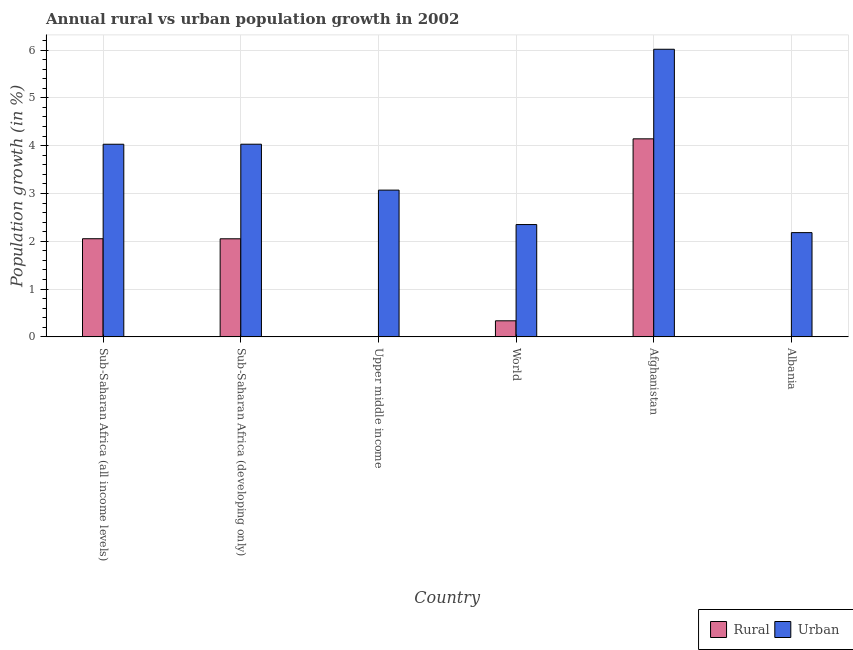How many bars are there on the 2nd tick from the right?
Your answer should be compact. 2. What is the label of the 1st group of bars from the left?
Provide a short and direct response. Sub-Saharan Africa (all income levels). Across all countries, what is the maximum rural population growth?
Make the answer very short. 4.14. Across all countries, what is the minimum urban population growth?
Provide a short and direct response. 2.18. In which country was the rural population growth maximum?
Your answer should be compact. Afghanistan. What is the total rural population growth in the graph?
Your answer should be compact. 8.58. What is the difference between the urban population growth in Sub-Saharan Africa (all income levels) and that in Upper middle income?
Make the answer very short. 0.96. What is the difference between the rural population growth in Afghanistan and the urban population growth in Albania?
Make the answer very short. 1.96. What is the average rural population growth per country?
Ensure brevity in your answer.  1.43. What is the difference between the urban population growth and rural population growth in Sub-Saharan Africa (all income levels)?
Your answer should be very brief. 1.98. What is the ratio of the urban population growth in Afghanistan to that in Upper middle income?
Make the answer very short. 1.96. Is the difference between the urban population growth in Sub-Saharan Africa (all income levels) and World greater than the difference between the rural population growth in Sub-Saharan Africa (all income levels) and World?
Your response must be concise. No. What is the difference between the highest and the second highest urban population growth?
Your response must be concise. 1.99. What is the difference between the highest and the lowest urban population growth?
Provide a short and direct response. 3.84. Is the sum of the urban population growth in Albania and Upper middle income greater than the maximum rural population growth across all countries?
Provide a succinct answer. Yes. Are all the bars in the graph horizontal?
Your answer should be very brief. No. How many countries are there in the graph?
Your answer should be compact. 6. Does the graph contain grids?
Offer a terse response. Yes. How many legend labels are there?
Keep it short and to the point. 2. What is the title of the graph?
Your answer should be very brief. Annual rural vs urban population growth in 2002. Does "Savings" appear as one of the legend labels in the graph?
Give a very brief answer. No. What is the label or title of the Y-axis?
Give a very brief answer. Population growth (in %). What is the Population growth (in %) of Rural in Sub-Saharan Africa (all income levels)?
Make the answer very short. 2.05. What is the Population growth (in %) of Urban  in Sub-Saharan Africa (all income levels)?
Provide a short and direct response. 4.03. What is the Population growth (in %) in Rural in Sub-Saharan Africa (developing only)?
Offer a terse response. 2.05. What is the Population growth (in %) in Urban  in Sub-Saharan Africa (developing only)?
Offer a very short reply. 4.03. What is the Population growth (in %) of Rural in Upper middle income?
Provide a short and direct response. 0. What is the Population growth (in %) of Urban  in Upper middle income?
Keep it short and to the point. 3.07. What is the Population growth (in %) of Rural in World?
Your answer should be very brief. 0.34. What is the Population growth (in %) of Urban  in World?
Give a very brief answer. 2.35. What is the Population growth (in %) in Rural in Afghanistan?
Offer a very short reply. 4.14. What is the Population growth (in %) in Urban  in Afghanistan?
Your answer should be very brief. 6.02. What is the Population growth (in %) in Rural in Albania?
Ensure brevity in your answer.  0. What is the Population growth (in %) in Urban  in Albania?
Your response must be concise. 2.18. Across all countries, what is the maximum Population growth (in %) of Rural?
Offer a terse response. 4.14. Across all countries, what is the maximum Population growth (in %) of Urban ?
Keep it short and to the point. 6.02. Across all countries, what is the minimum Population growth (in %) of Rural?
Make the answer very short. 0. Across all countries, what is the minimum Population growth (in %) in Urban ?
Provide a short and direct response. 2.18. What is the total Population growth (in %) of Rural in the graph?
Ensure brevity in your answer.  8.58. What is the total Population growth (in %) of Urban  in the graph?
Offer a terse response. 21.68. What is the difference between the Population growth (in %) in Rural in Sub-Saharan Africa (all income levels) and that in Sub-Saharan Africa (developing only)?
Your answer should be compact. 0. What is the difference between the Population growth (in %) of Urban  in Sub-Saharan Africa (all income levels) and that in Sub-Saharan Africa (developing only)?
Offer a terse response. -0. What is the difference between the Population growth (in %) of Urban  in Sub-Saharan Africa (all income levels) and that in Upper middle income?
Provide a short and direct response. 0.96. What is the difference between the Population growth (in %) of Rural in Sub-Saharan Africa (all income levels) and that in World?
Offer a very short reply. 1.72. What is the difference between the Population growth (in %) in Urban  in Sub-Saharan Africa (all income levels) and that in World?
Ensure brevity in your answer.  1.68. What is the difference between the Population growth (in %) in Rural in Sub-Saharan Africa (all income levels) and that in Afghanistan?
Ensure brevity in your answer.  -2.09. What is the difference between the Population growth (in %) of Urban  in Sub-Saharan Africa (all income levels) and that in Afghanistan?
Offer a terse response. -1.99. What is the difference between the Population growth (in %) in Urban  in Sub-Saharan Africa (all income levels) and that in Albania?
Your answer should be very brief. 1.85. What is the difference between the Population growth (in %) in Urban  in Sub-Saharan Africa (developing only) and that in Upper middle income?
Give a very brief answer. 0.96. What is the difference between the Population growth (in %) of Rural in Sub-Saharan Africa (developing only) and that in World?
Your answer should be very brief. 1.72. What is the difference between the Population growth (in %) in Urban  in Sub-Saharan Africa (developing only) and that in World?
Provide a short and direct response. 1.68. What is the difference between the Population growth (in %) of Rural in Sub-Saharan Africa (developing only) and that in Afghanistan?
Offer a very short reply. -2.09. What is the difference between the Population growth (in %) of Urban  in Sub-Saharan Africa (developing only) and that in Afghanistan?
Offer a terse response. -1.99. What is the difference between the Population growth (in %) of Urban  in Sub-Saharan Africa (developing only) and that in Albania?
Offer a terse response. 1.85. What is the difference between the Population growth (in %) in Urban  in Upper middle income and that in World?
Give a very brief answer. 0.72. What is the difference between the Population growth (in %) in Urban  in Upper middle income and that in Afghanistan?
Keep it short and to the point. -2.95. What is the difference between the Population growth (in %) of Urban  in Upper middle income and that in Albania?
Ensure brevity in your answer.  0.89. What is the difference between the Population growth (in %) of Rural in World and that in Afghanistan?
Offer a very short reply. -3.81. What is the difference between the Population growth (in %) of Urban  in World and that in Afghanistan?
Your response must be concise. -3.67. What is the difference between the Population growth (in %) of Urban  in World and that in Albania?
Make the answer very short. 0.17. What is the difference between the Population growth (in %) in Urban  in Afghanistan and that in Albania?
Your response must be concise. 3.84. What is the difference between the Population growth (in %) of Rural in Sub-Saharan Africa (all income levels) and the Population growth (in %) of Urban  in Sub-Saharan Africa (developing only)?
Your answer should be compact. -1.98. What is the difference between the Population growth (in %) in Rural in Sub-Saharan Africa (all income levels) and the Population growth (in %) in Urban  in Upper middle income?
Your answer should be compact. -1.02. What is the difference between the Population growth (in %) in Rural in Sub-Saharan Africa (all income levels) and the Population growth (in %) in Urban  in World?
Offer a very short reply. -0.3. What is the difference between the Population growth (in %) in Rural in Sub-Saharan Africa (all income levels) and the Population growth (in %) in Urban  in Afghanistan?
Make the answer very short. -3.96. What is the difference between the Population growth (in %) of Rural in Sub-Saharan Africa (all income levels) and the Population growth (in %) of Urban  in Albania?
Your answer should be compact. -0.13. What is the difference between the Population growth (in %) of Rural in Sub-Saharan Africa (developing only) and the Population growth (in %) of Urban  in Upper middle income?
Make the answer very short. -1.02. What is the difference between the Population growth (in %) in Rural in Sub-Saharan Africa (developing only) and the Population growth (in %) in Urban  in World?
Provide a short and direct response. -0.3. What is the difference between the Population growth (in %) of Rural in Sub-Saharan Africa (developing only) and the Population growth (in %) of Urban  in Afghanistan?
Make the answer very short. -3.96. What is the difference between the Population growth (in %) of Rural in Sub-Saharan Africa (developing only) and the Population growth (in %) of Urban  in Albania?
Provide a short and direct response. -0.13. What is the difference between the Population growth (in %) of Rural in World and the Population growth (in %) of Urban  in Afghanistan?
Offer a terse response. -5.68. What is the difference between the Population growth (in %) of Rural in World and the Population growth (in %) of Urban  in Albania?
Your answer should be very brief. -1.84. What is the difference between the Population growth (in %) of Rural in Afghanistan and the Population growth (in %) of Urban  in Albania?
Give a very brief answer. 1.96. What is the average Population growth (in %) in Rural per country?
Your answer should be very brief. 1.43. What is the average Population growth (in %) in Urban  per country?
Offer a very short reply. 3.61. What is the difference between the Population growth (in %) of Rural and Population growth (in %) of Urban  in Sub-Saharan Africa (all income levels)?
Make the answer very short. -1.98. What is the difference between the Population growth (in %) of Rural and Population growth (in %) of Urban  in Sub-Saharan Africa (developing only)?
Keep it short and to the point. -1.98. What is the difference between the Population growth (in %) of Rural and Population growth (in %) of Urban  in World?
Offer a terse response. -2.01. What is the difference between the Population growth (in %) in Rural and Population growth (in %) in Urban  in Afghanistan?
Your answer should be very brief. -1.87. What is the ratio of the Population growth (in %) of Rural in Sub-Saharan Africa (all income levels) to that in Sub-Saharan Africa (developing only)?
Ensure brevity in your answer.  1. What is the ratio of the Population growth (in %) of Urban  in Sub-Saharan Africa (all income levels) to that in Upper middle income?
Keep it short and to the point. 1.31. What is the ratio of the Population growth (in %) in Rural in Sub-Saharan Africa (all income levels) to that in World?
Your answer should be very brief. 6.11. What is the ratio of the Population growth (in %) of Urban  in Sub-Saharan Africa (all income levels) to that in World?
Your response must be concise. 1.72. What is the ratio of the Population growth (in %) in Rural in Sub-Saharan Africa (all income levels) to that in Afghanistan?
Provide a short and direct response. 0.5. What is the ratio of the Population growth (in %) of Urban  in Sub-Saharan Africa (all income levels) to that in Afghanistan?
Keep it short and to the point. 0.67. What is the ratio of the Population growth (in %) of Urban  in Sub-Saharan Africa (all income levels) to that in Albania?
Your answer should be very brief. 1.85. What is the ratio of the Population growth (in %) of Urban  in Sub-Saharan Africa (developing only) to that in Upper middle income?
Your response must be concise. 1.31. What is the ratio of the Population growth (in %) in Rural in Sub-Saharan Africa (developing only) to that in World?
Your answer should be very brief. 6.1. What is the ratio of the Population growth (in %) in Urban  in Sub-Saharan Africa (developing only) to that in World?
Provide a succinct answer. 1.72. What is the ratio of the Population growth (in %) in Rural in Sub-Saharan Africa (developing only) to that in Afghanistan?
Ensure brevity in your answer.  0.5. What is the ratio of the Population growth (in %) in Urban  in Sub-Saharan Africa (developing only) to that in Afghanistan?
Ensure brevity in your answer.  0.67. What is the ratio of the Population growth (in %) in Urban  in Sub-Saharan Africa (developing only) to that in Albania?
Make the answer very short. 1.85. What is the ratio of the Population growth (in %) of Urban  in Upper middle income to that in World?
Provide a short and direct response. 1.31. What is the ratio of the Population growth (in %) in Urban  in Upper middle income to that in Afghanistan?
Provide a succinct answer. 0.51. What is the ratio of the Population growth (in %) in Urban  in Upper middle income to that in Albania?
Keep it short and to the point. 1.41. What is the ratio of the Population growth (in %) in Rural in World to that in Afghanistan?
Make the answer very short. 0.08. What is the ratio of the Population growth (in %) in Urban  in World to that in Afghanistan?
Offer a very short reply. 0.39. What is the ratio of the Population growth (in %) of Urban  in World to that in Albania?
Provide a succinct answer. 1.08. What is the ratio of the Population growth (in %) in Urban  in Afghanistan to that in Albania?
Give a very brief answer. 2.76. What is the difference between the highest and the second highest Population growth (in %) of Rural?
Make the answer very short. 2.09. What is the difference between the highest and the second highest Population growth (in %) of Urban ?
Your answer should be compact. 1.99. What is the difference between the highest and the lowest Population growth (in %) of Rural?
Give a very brief answer. 4.14. What is the difference between the highest and the lowest Population growth (in %) in Urban ?
Make the answer very short. 3.84. 